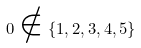Convert formula to latex. <formula><loc_0><loc_0><loc_500><loc_500>0 \notin \{ 1 , 2 , 3 , 4 , 5 \}</formula> 